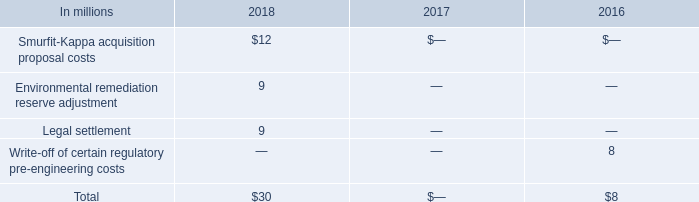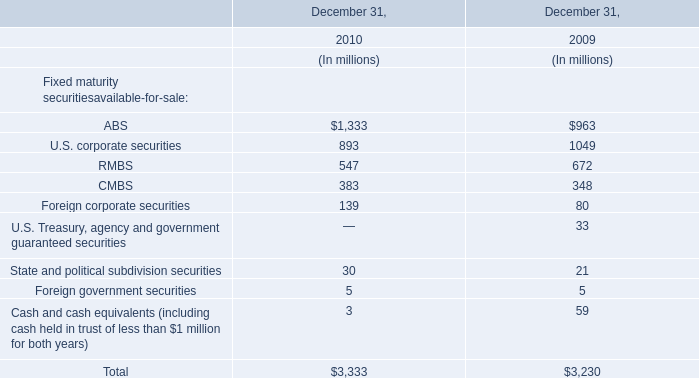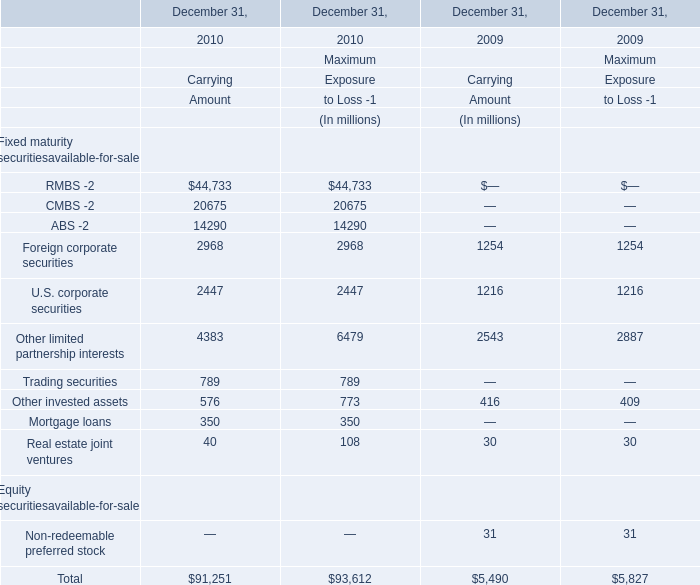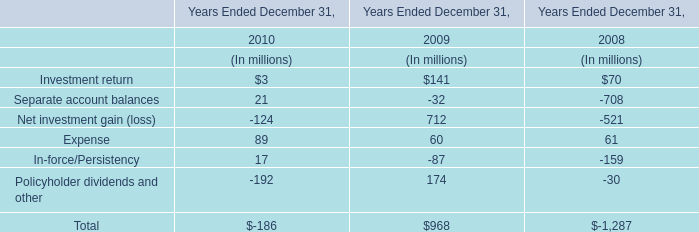What was the total amount of Carrying Amount in 2010 for Fixed maturity securitiesavailable-for-sale? (in million) 
Computations: (((((((((44733 + 20675) + 14290) + 2968) + 2447) + 4383) + 789) + 576) + 350) + 40)
Answer: 91251.0. 